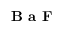Convert formula to latex. <formula><loc_0><loc_0><loc_500><loc_500>B a F</formula> 